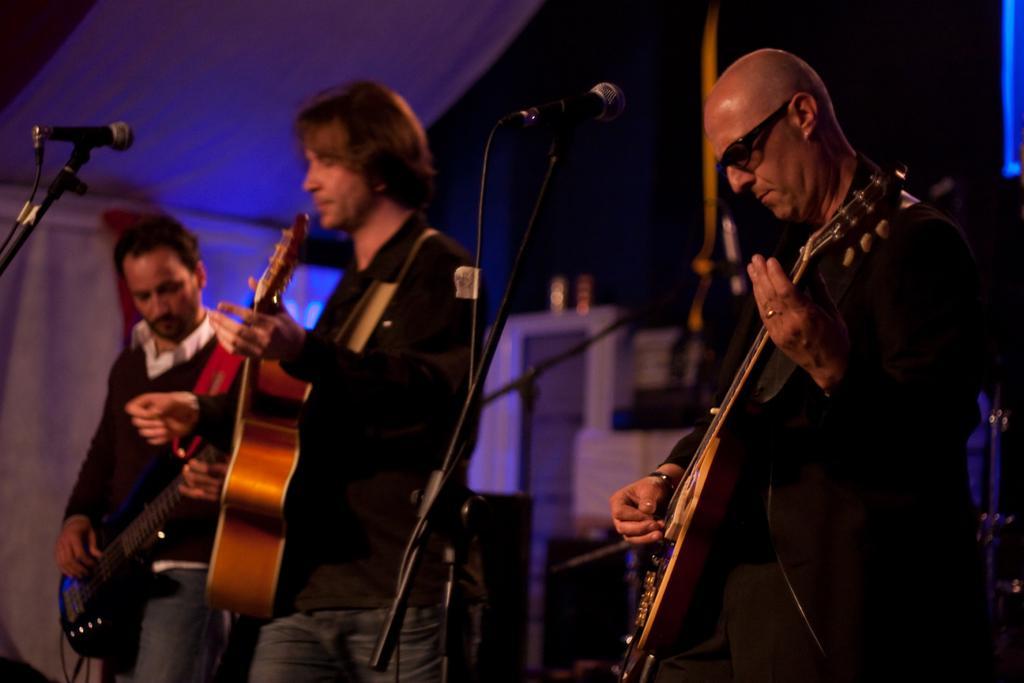Could you give a brief overview of what you see in this image? In this image there are three persons playing guitar. In front of them there are mic. They are wearing black dress. It seems like they are standing under a tent. 